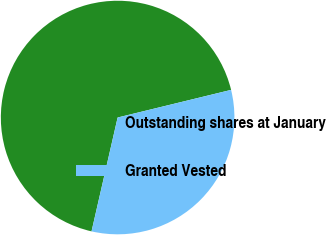Convert chart to OTSL. <chart><loc_0><loc_0><loc_500><loc_500><pie_chart><fcel>Outstanding shares at January<fcel>Granted Vested<nl><fcel>67.61%<fcel>32.39%<nl></chart> 